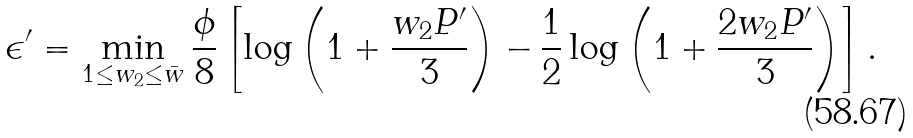<formula> <loc_0><loc_0><loc_500><loc_500>\epsilon ^ { \prime } = \min _ { 1 \leq w _ { 2 } \leq \bar { w } } \frac { \phi } { 8 } \left [ \log \left ( 1 + \frac { w _ { 2 } P ^ { \prime } } { 3 } \right ) - \frac { 1 } { 2 } \log \left ( 1 + \frac { 2 w _ { 2 } P ^ { \prime } } { 3 } \right ) \right ] .</formula> 